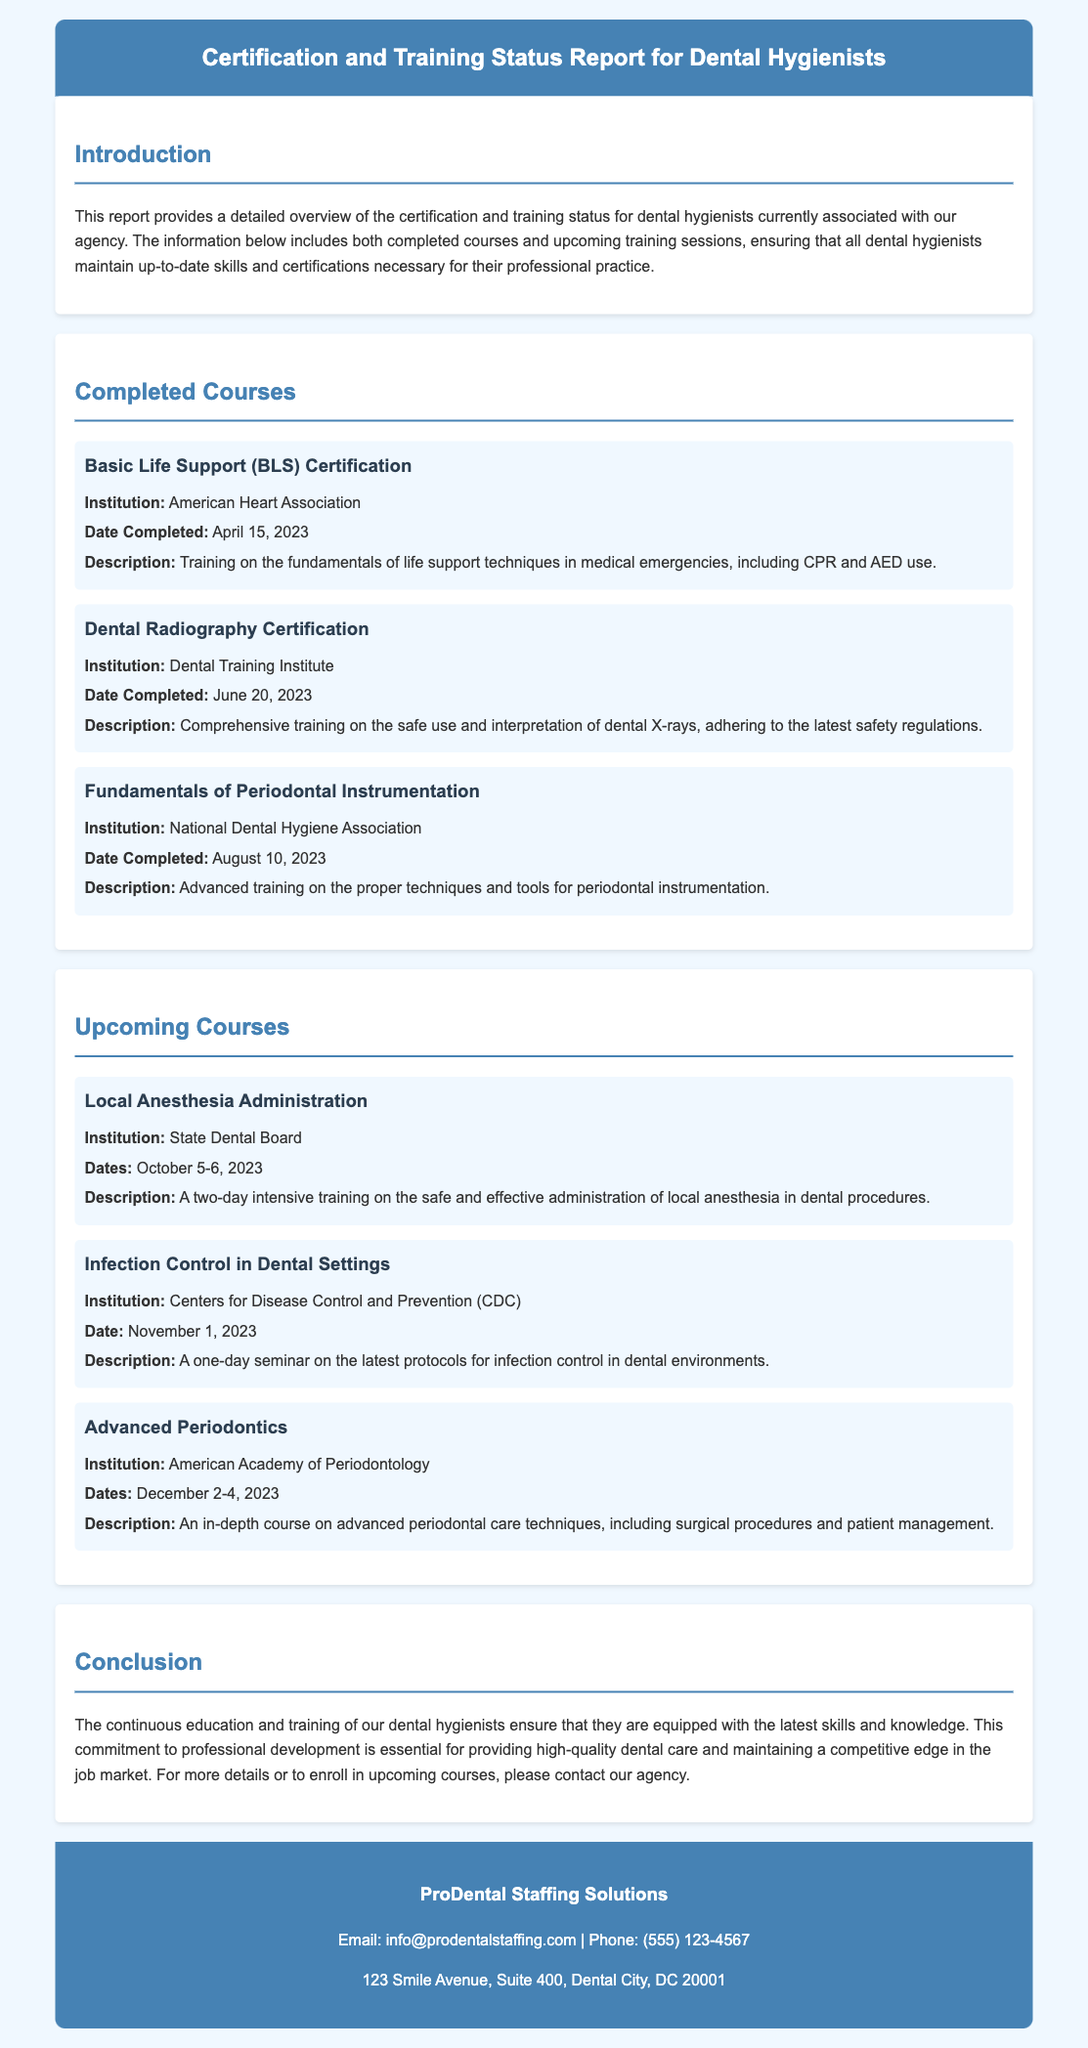What is the title of the report? The title of the report is provided in the header, detailing the focus on certification and training for dental hygienists.
Answer: Certification and Training Status Report for Dental Hygienists Who completed the Basic Life Support certification? The institution that provided the Basic Life Support certification is mentioned in the document as the American Heart Association.
Answer: American Heart Association What is the date of the upcoming Local Anesthesia Administration course? The course dates are explicitly listed in the upcoming courses section of the document.
Answer: October 5-6, 2023 What institution is offering the Infection Control seminar? The document specifies that the seminar on Infection Control is offered by the Centers for Disease Control and Prevention.
Answer: Centers for Disease Control and Prevention (CDC) How many completed courses are listed in the document? The document presents a section on completed courses, and the number of presented courses is counted to answer this question.
Answer: Three What type of training is offered in the Advanced Periodontics course? The course description mentions advanced techniques and procedures related to periodontal care.
Answer: Advanced periodontal care techniques When will the Advanced Periodontics course take place? The document clearly states the dates for the Advanced Periodontics course in the upcoming section.
Answer: December 2-4, 2023 What is the main purpose of the report? The introduction outlines the report's purpose of providing an overview of certification and training status for dental hygienists.
Answer: Overview of the certification and training status What is the contact email for ProDental Staffing Solutions? The footer of the document lists the contact email address for the agency.
Answer: info@prodentalstaffing.com 